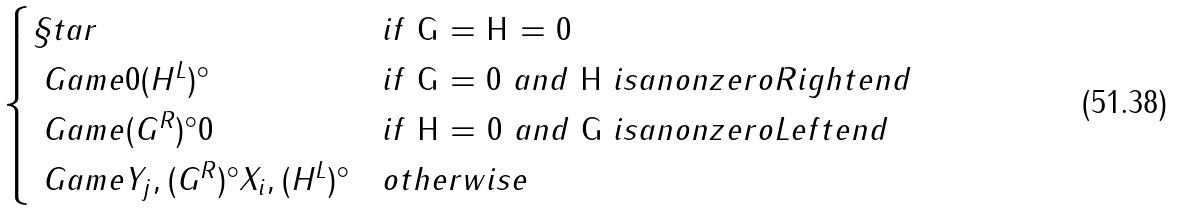<formula> <loc_0><loc_0><loc_500><loc_500>\begin{cases} \S t a r & i f $ G = H = 0 $ \\ \ G a m e { 0 } { ( H ^ { L } ) ^ { \circ } } & i f $ G = 0 $ a n d $ H $ i s a n o n z e r o R i g h t e n d \\ \ G a m e { ( G ^ { R } ) ^ { \circ } } { 0 } & i f $ H = 0 $ a n d $ G $ i s a n o n z e r o L e f t e n d \\ \ G a m e { Y _ { j } , ( G ^ { R } ) ^ { \circ } } { X _ { i } , ( H ^ { L } ) ^ { \circ } } & o t h e r w i s e \end{cases}</formula> 